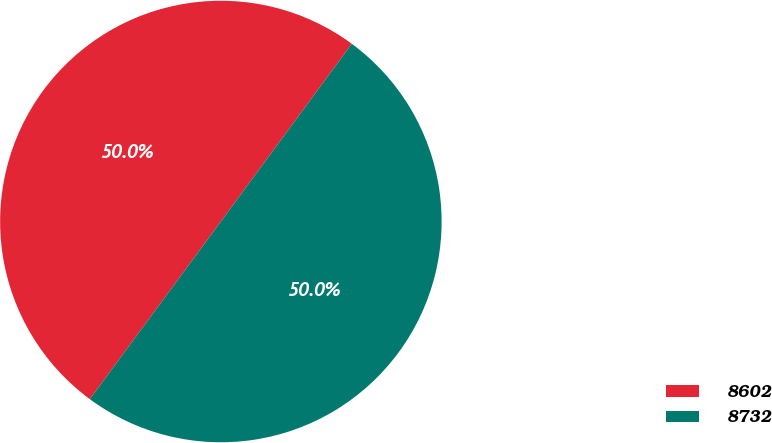<chart> <loc_0><loc_0><loc_500><loc_500><pie_chart><fcel>8602<fcel>8732<nl><fcel>49.99%<fcel>50.01%<nl></chart> 